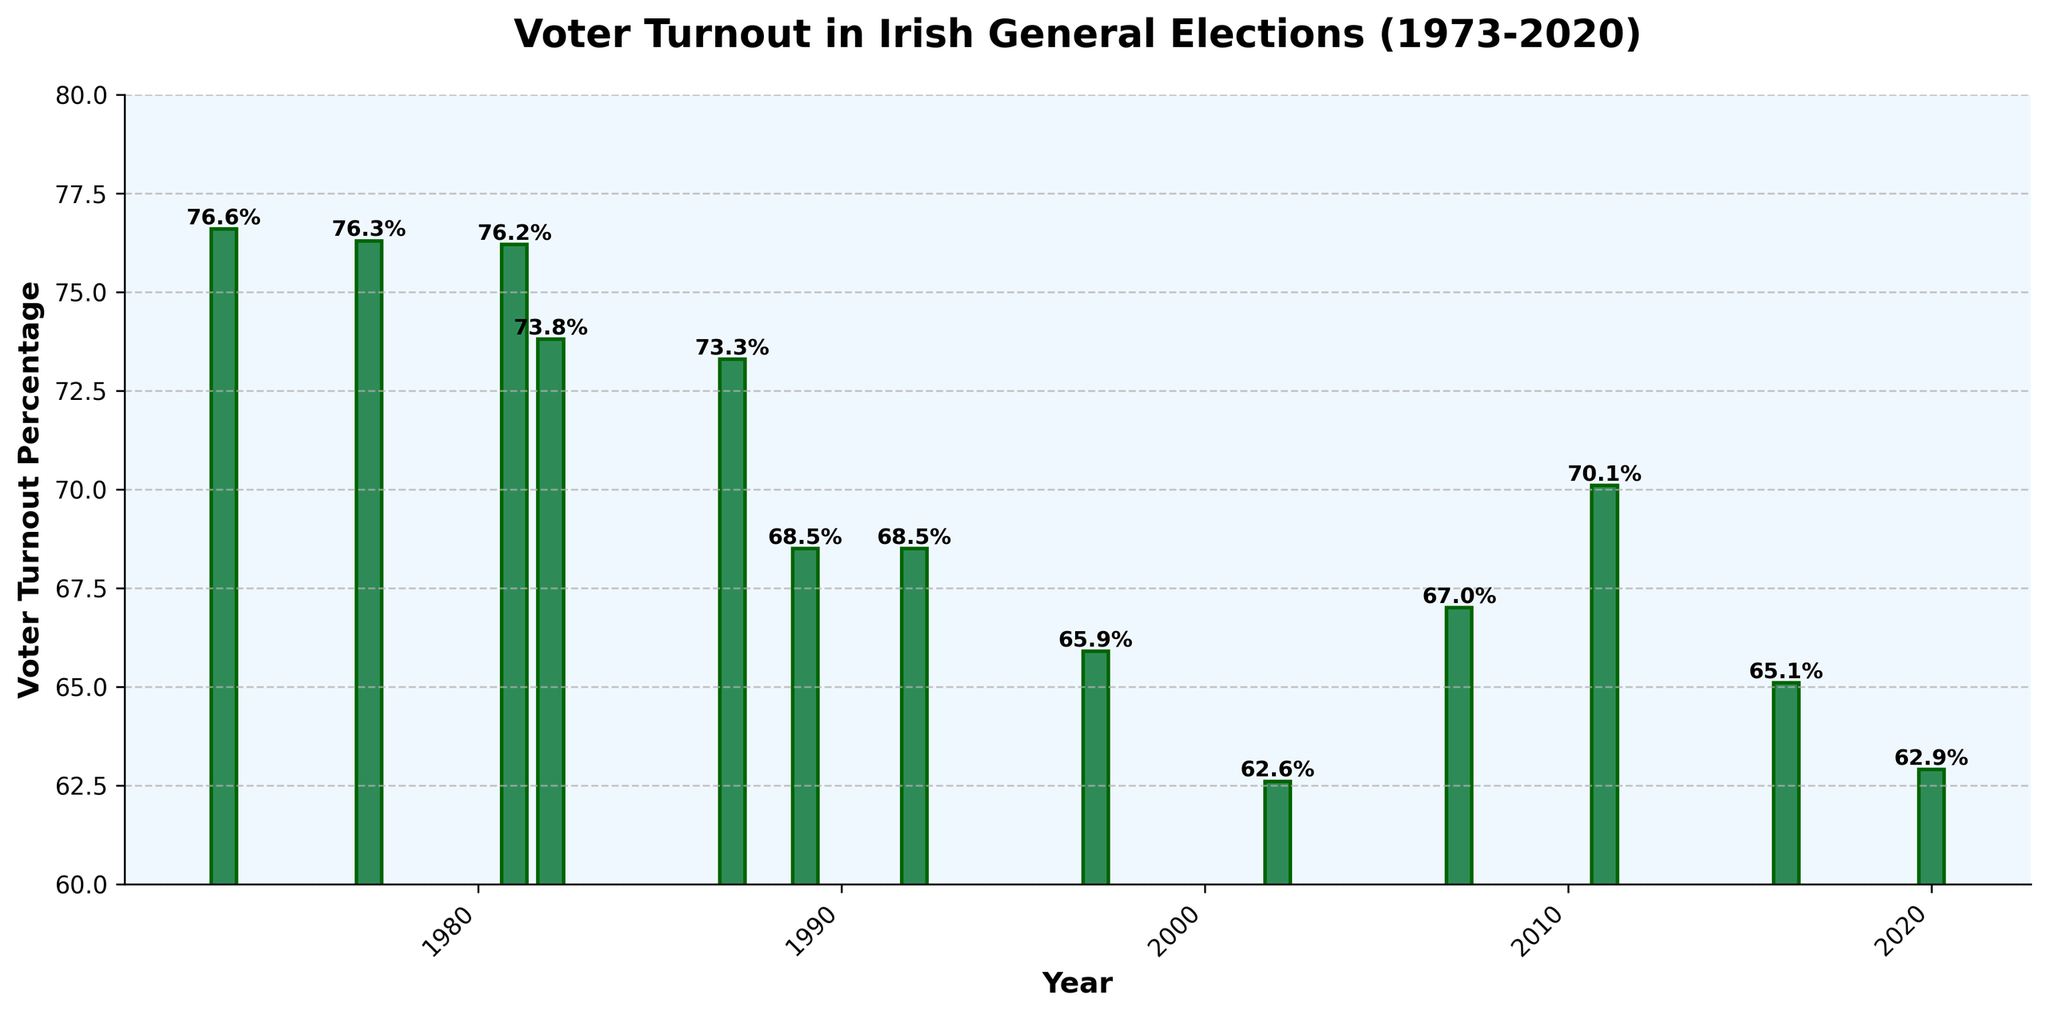What's the highest voter turnout percentage in the figure? To find the highest voter turnout, look at the top of each bar to see the value labels. The highest value displayed is in 1973 with 76.6%.
Answer: 76.6% What's the lowest voter turnout percentage in the figure? To find the lowest voter turnout, look for the shortest bar since shorter bars represent lower percentages. The lowest is in 2002 with 62.6%.
Answer: 62.6% How many years had a voter turnout percentage of equal to or above 70%? Identify the bars with value labels equal to or above 70%. The years are 1973, 1977, 1981, 1982, 1987, 2011, summing up to 6 years.
Answer: 6 What is the difference in voter turnout percentage between 2002 and 2020? Find the voter turnout for 2002 (62.6%) and 2020 (62.9%). Subtract the smaller value from the larger value: 62.9% - 62.6% = 0.3%.
Answer: 0.3% Which year had a lower voter turnout, 1997 or 2007? Compare the value labels for 1997 (65.9%) and 2007 (67.0%). The lower turnout was in 1997.
Answer: 1997 What is the average voter turnout percentage over the last 50 years? Add all voter turnout values: 76.6 + 76.3 + 76.2 + 73.8 + 73.3 + 68.5 + 68.5 + 65.9 + 62.6 + 67.0 + 70.1 + 65.1 + 62.9 = 906.8. Divide by the number of years (13): 906.8 / 13 ≈ 69.8%.
Answer: 69.8% Between which consecutive years did voter turnout drop the most? Calculate the difference between each pair of consecutive years. The largest drop is between 1987 (73.3%) and 1989 (68.5%): 73.3% - 68.5% = 4.8%.
Answer: 1987 and 1989 Did voter turnout ever increase consecutively in three or more elections? Examine the bars to see if there are three consecutive increases. No such pattern is visible; the highest consecutive increase is between 2002 (62.6%), 2007 (67.0%), and 2011 (70.1%), which is a rise in two consecutive elections.
Answer: No Which decade had the overall lowest voter turnout percentage? Check each decade:
- 1970s average: (76.6 + 76.3) / 2 = 76.45%
- 1980s average: (76.2 + 73.8 + 73.3 + 68.5) / 4 ≈ 72.95%
- 1990s average: (68.5 + 65.9) / 2 = 67.2%
- 2000s average: (62.6 + 67.0) / 2 = 64.8%
- 2010s and 2020s average: (70.1 + 65.1 + 62.9) / 3 ≈ 66.03%
The 2000s had the lowest voter turnout percentage with 64.8%.
Answer: 2000s What was the percentage of voter turnout in the election with the last visual bar? The last bar represents the year 2020 with a voter turnout percentage of 62.9%.
Answer: 62.9% 